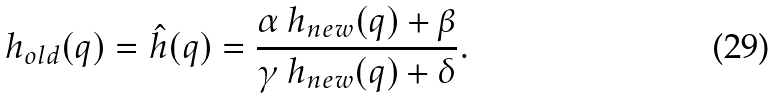<formula> <loc_0><loc_0><loc_500><loc_500>h _ { o l d } ( q ) = \hat { h } ( q ) = \frac { \alpha \, h _ { n e w } ( q ) + \beta } { \gamma \, h _ { n e w } ( q ) + \delta } .</formula> 